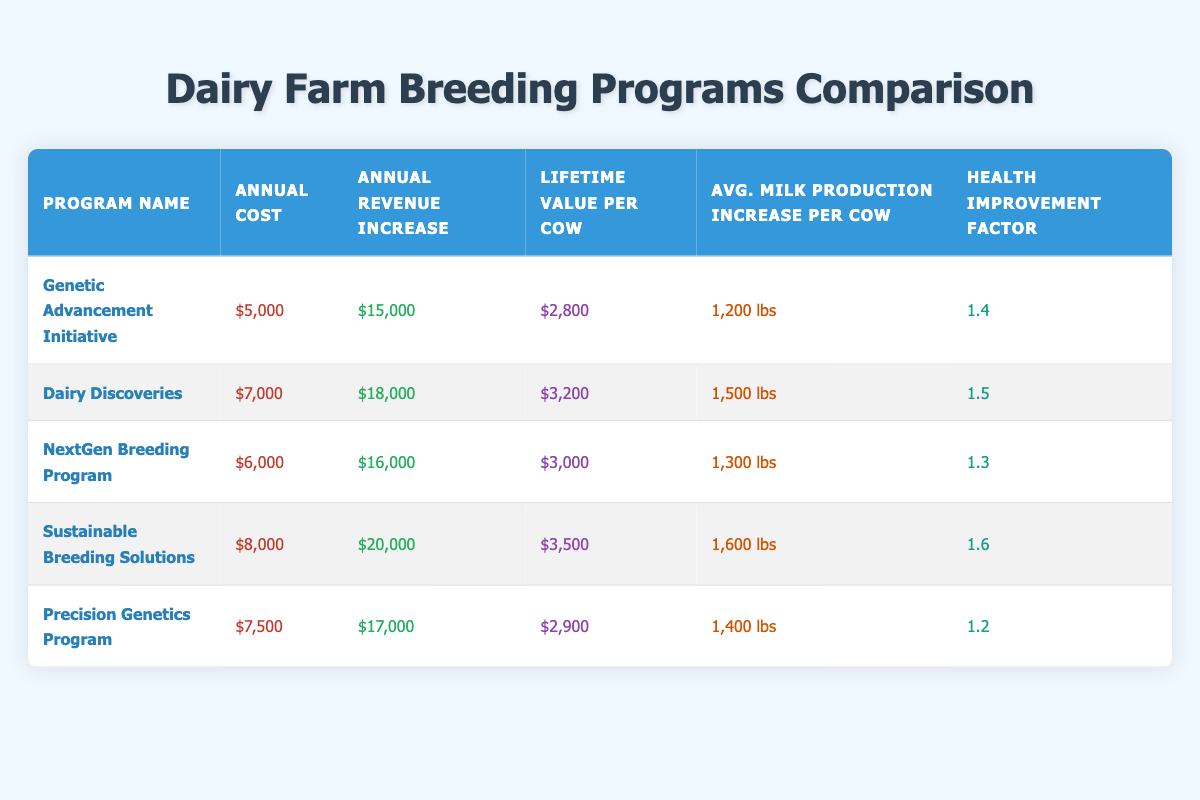What is the annual revenue increase for the Sustainable Breeding Solutions program? From the table, we see that the Sustainable Breeding Solutions program has an annual revenue increase listed as $20,000.
Answer: $20,000 What is the lifetime value per cow for the Dairy Discoveries program? The table indicates that the Dairy Discoveries program has a lifetime value per cow of $3,200.
Answer: $3,200 Which breeding program has the highest annual cost? By looking at the "Annual Cost" column, we see that the Sustainable Breeding Solutions program has the highest cost at $8,000.
Answer: $8,000 What is the average milk production increase across all programs? First, we sum the average milk production increases: 1200 + 1500 + 1300 + 1600 + 1400 = 7000. Next, we divide by the number of programs (5), resulting in an average of 7000 / 5 = 1400 lbs.
Answer: 1400 lbs Is the health improvement factor for the Genetic Advancement Initiative greater than 1.4? From the table, we see the health improvement factor for Genetic Advancement Initiative is exactly 1.4, so it is not greater than 1.4.
Answer: No Which program results in the greatest increase in average milk production per cow? Examining the "Avg. Milk Production Increase per Cow" column, we find that the Sustainable Breeding Solutions program has the highest increase of 1600 lbs.
Answer: 1600 lbs What is the total annual revenue increase for all programs combined? We add up the annual revenue increases: 15000 + 18000 + 16000 + 20000 + 17000 = 106000.
Answer: $106,000 Which program has the lowest lifetime value per cow, and what is that value? The table shows that the Genetic Advancement Initiative has the lowest lifetime value per cow at $2,800.
Answer: $2,800 If you compare the annual cost and annual revenue increase for the NextGen Breeding Program, does the revenue increase outweigh the cost? The annual cost for the NextGen Breeding Program is $6,000 and the revenue increase is $16,000. Since $16,000 exceeds $6,000, the revenue indeed outweighs the cost.
Answer: Yes 